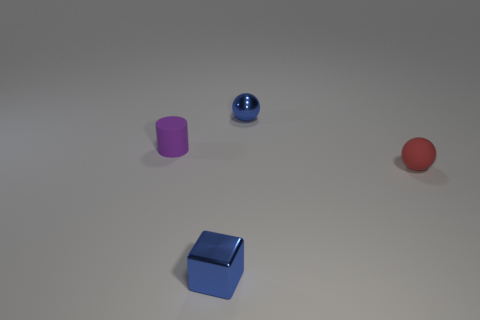How many other objects are there of the same shape as the red object?
Offer a terse response. 1. There is a purple rubber thing; is it the same size as the shiny thing that is behind the tiny block?
Provide a short and direct response. Yes. What number of objects are either objects in front of the red object or purple cylinders?
Your answer should be very brief. 2. What shape is the thing that is behind the purple cylinder?
Make the answer very short. Sphere. Is the number of small metal things that are behind the rubber ball the same as the number of small metal objects that are on the left side of the tiny metal block?
Keep it short and to the point. No. The object that is both to the left of the blue ball and behind the red matte ball is what color?
Keep it short and to the point. Purple. There is a small blue thing that is on the right side of the small blue thing in front of the tiny purple rubber cylinder; what is its material?
Your answer should be very brief. Metal. Is the size of the red object the same as the purple matte cylinder?
Give a very brief answer. Yes. What number of small objects are things or matte spheres?
Make the answer very short. 4. There is a tiny matte cylinder; what number of matte things are in front of it?
Provide a short and direct response. 1. 